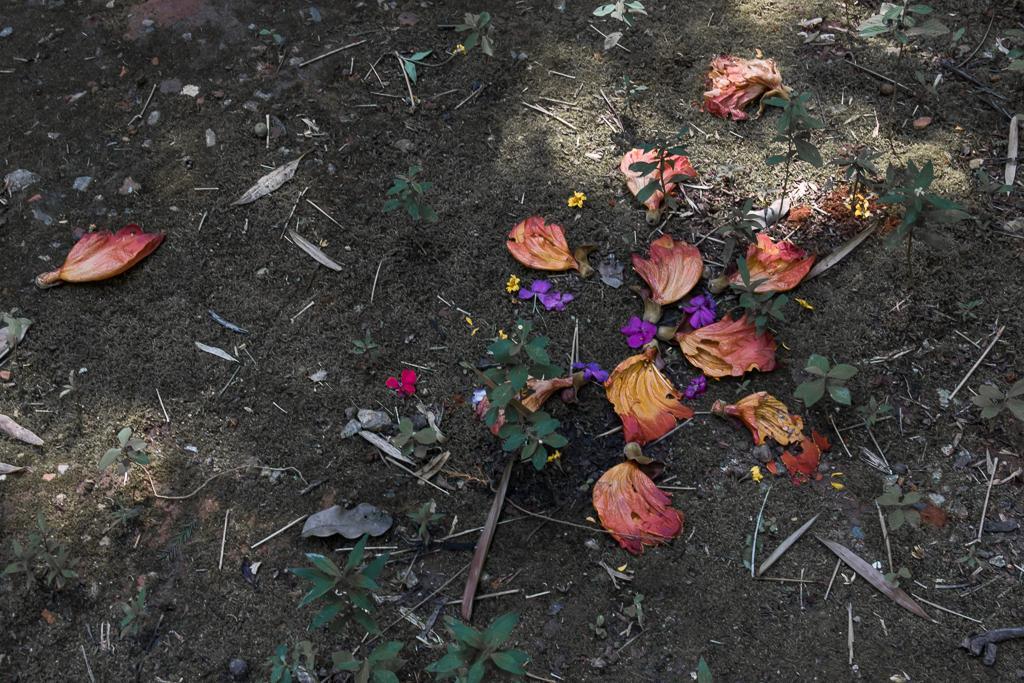Please provide a concise description of this image. In this image we can see flowers and plants on the ground. 